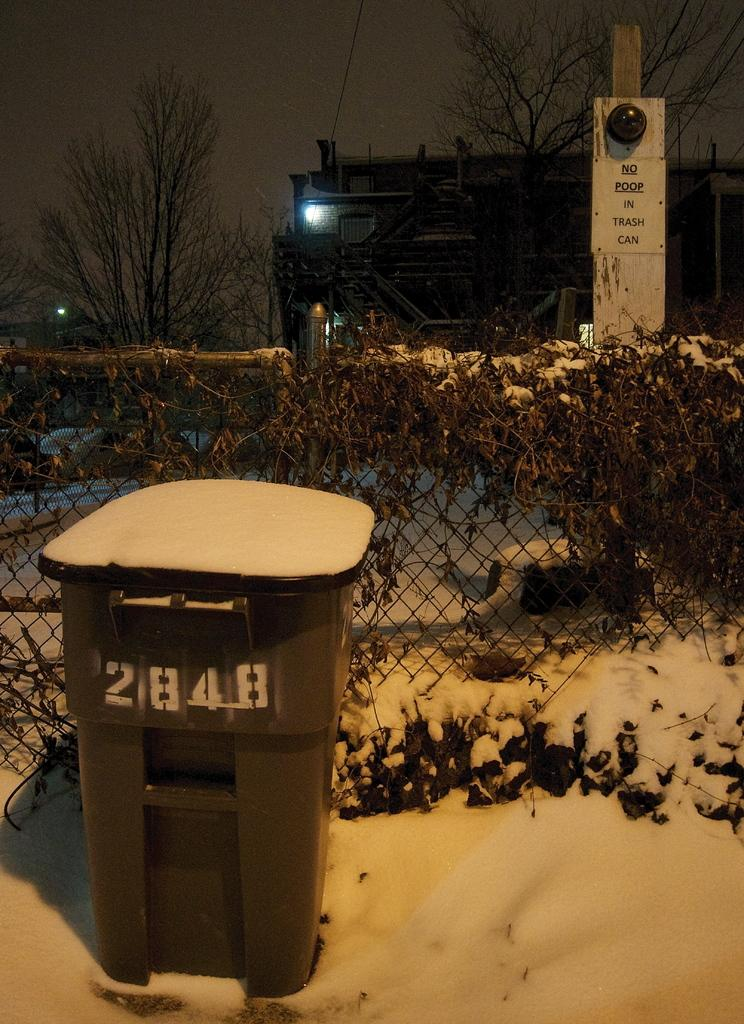<image>
Describe the image concisely. A trash can covered in snow has the number 2848 on it. 